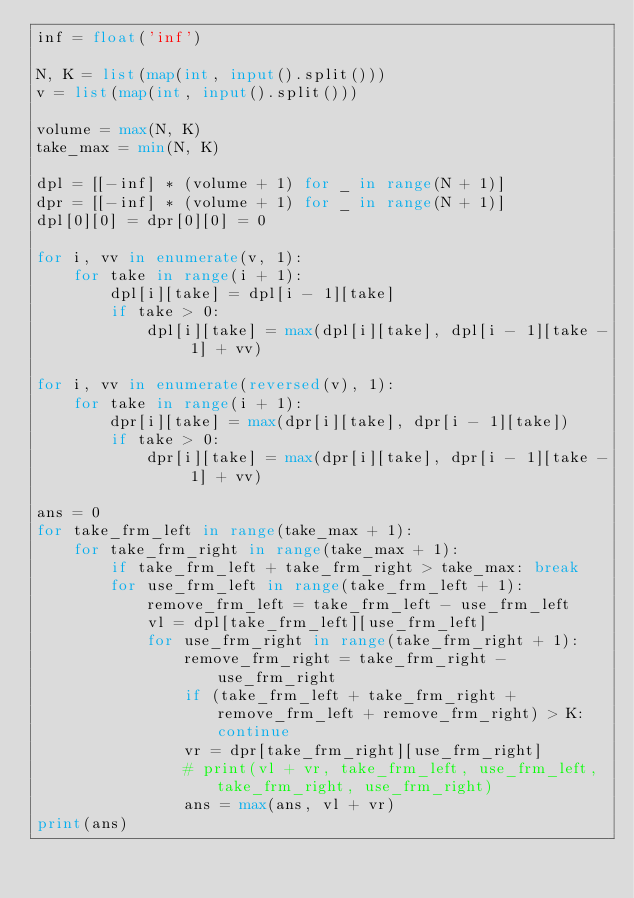Convert code to text. <code><loc_0><loc_0><loc_500><loc_500><_Python_>inf = float('inf')

N, K = list(map(int, input().split()))
v = list(map(int, input().split()))

volume = max(N, K)
take_max = min(N, K)

dpl = [[-inf] * (volume + 1) for _ in range(N + 1)]
dpr = [[-inf] * (volume + 1) for _ in range(N + 1)]
dpl[0][0] = dpr[0][0] = 0

for i, vv in enumerate(v, 1):
    for take in range(i + 1):
        dpl[i][take] = dpl[i - 1][take]
        if take > 0:
            dpl[i][take] = max(dpl[i][take], dpl[i - 1][take - 1] + vv)

for i, vv in enumerate(reversed(v), 1):
    for take in range(i + 1):
        dpr[i][take] = max(dpr[i][take], dpr[i - 1][take])
        if take > 0:
            dpr[i][take] = max(dpr[i][take], dpr[i - 1][take - 1] + vv)

ans = 0
for take_frm_left in range(take_max + 1):
    for take_frm_right in range(take_max + 1):
        if take_frm_left + take_frm_right > take_max: break
        for use_frm_left in range(take_frm_left + 1):
            remove_frm_left = take_frm_left - use_frm_left
            vl = dpl[take_frm_left][use_frm_left]
            for use_frm_right in range(take_frm_right + 1):
                remove_frm_right = take_frm_right - use_frm_right
                if (take_frm_left + take_frm_right + remove_frm_left + remove_frm_right) > K: continue
                vr = dpr[take_frm_right][use_frm_right]
                # print(vl + vr, take_frm_left, use_frm_left, take_frm_right, use_frm_right)
                ans = max(ans, vl + vr)
print(ans)
</code> 